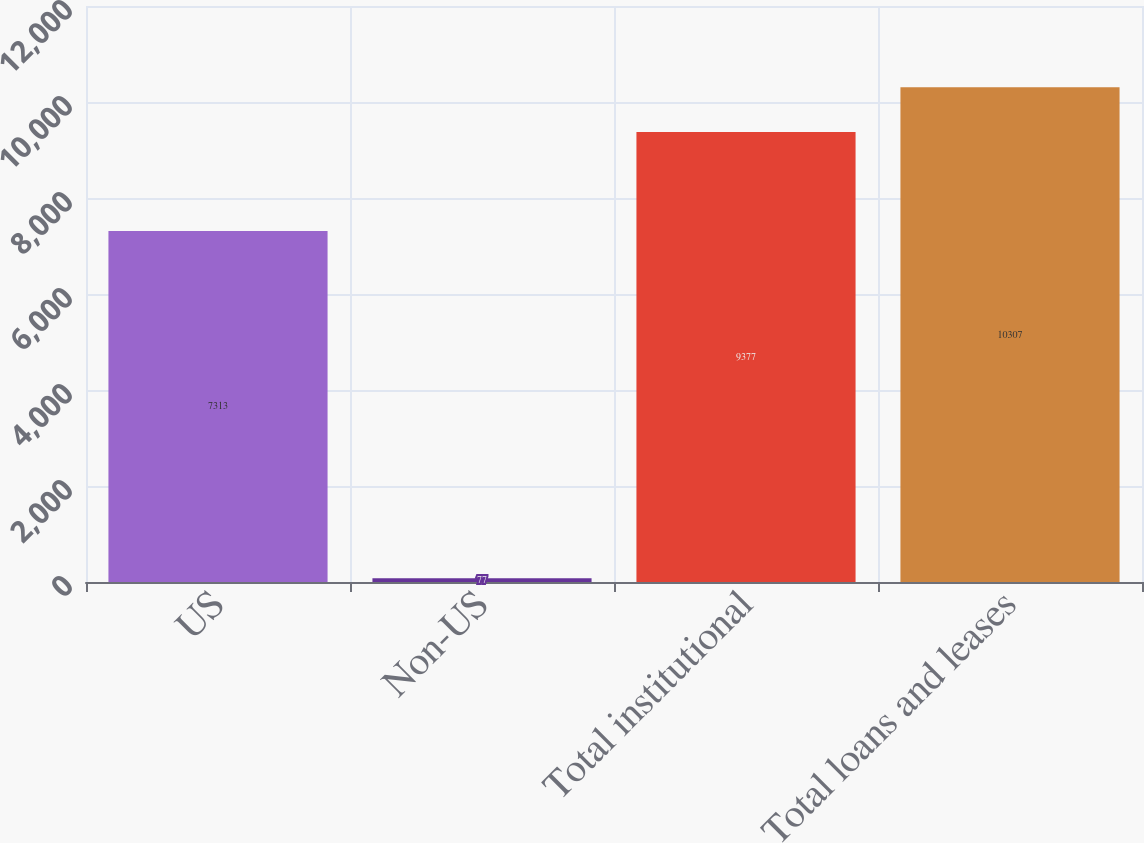Convert chart. <chart><loc_0><loc_0><loc_500><loc_500><bar_chart><fcel>US<fcel>Non-US<fcel>Total institutional<fcel>Total loans and leases<nl><fcel>7313<fcel>77<fcel>9377<fcel>10307<nl></chart> 